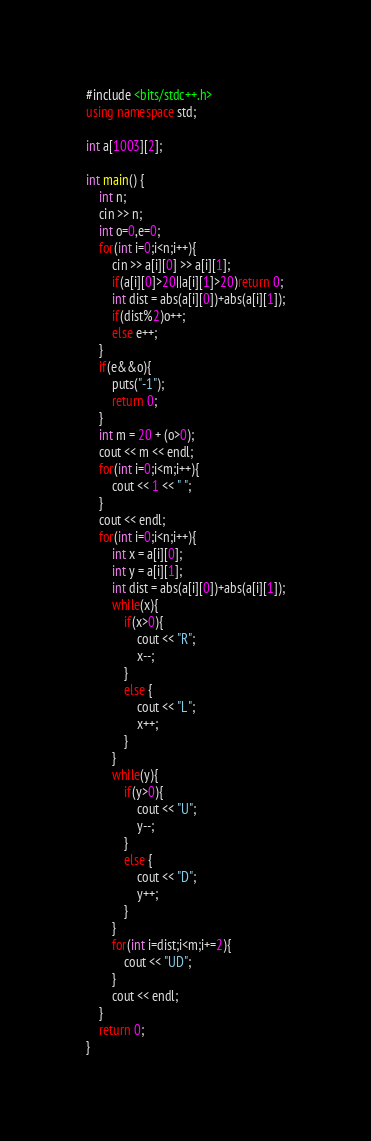<code> <loc_0><loc_0><loc_500><loc_500><_C++_>#include <bits/stdc++.h>
using namespace std;

int a[1003][2];

int main() {
    int n;
    cin >> n;
    int o=0,e=0;
    for(int i=0;i<n;i++){
        cin >> a[i][0] >> a[i][1];
        if(a[i][0]>20||a[i][1]>20)return 0;
        int dist = abs(a[i][0])+abs(a[i][1]);
        if(dist%2)o++;
        else e++;
    }
    if(e&&o){
        puts("-1");
        return 0;
    }
    int m = 20 + (o>0);
    cout << m << endl;
    for(int i=0;i<m;i++){
        cout << 1 << " ";
    }
    cout << endl;
    for(int i=0;i<n;i++){
        int x = a[i][0];
        int y = a[i][1];
        int dist = abs(a[i][0])+abs(a[i][1]);
        while(x){
            if(x>0){
                cout << "R";
                x--;
            }
            else {
                cout << "L";
                x++;
            }
        }
        while(y){
            if(y>0){
                cout << "U";
                y--;
            }
            else {
                cout << "D";
                y++;
            }
        }
        for(int i=dist;i<m;i+=2){
            cout << "UD";
        }
        cout << endl;
    }
    return 0;
}
</code> 